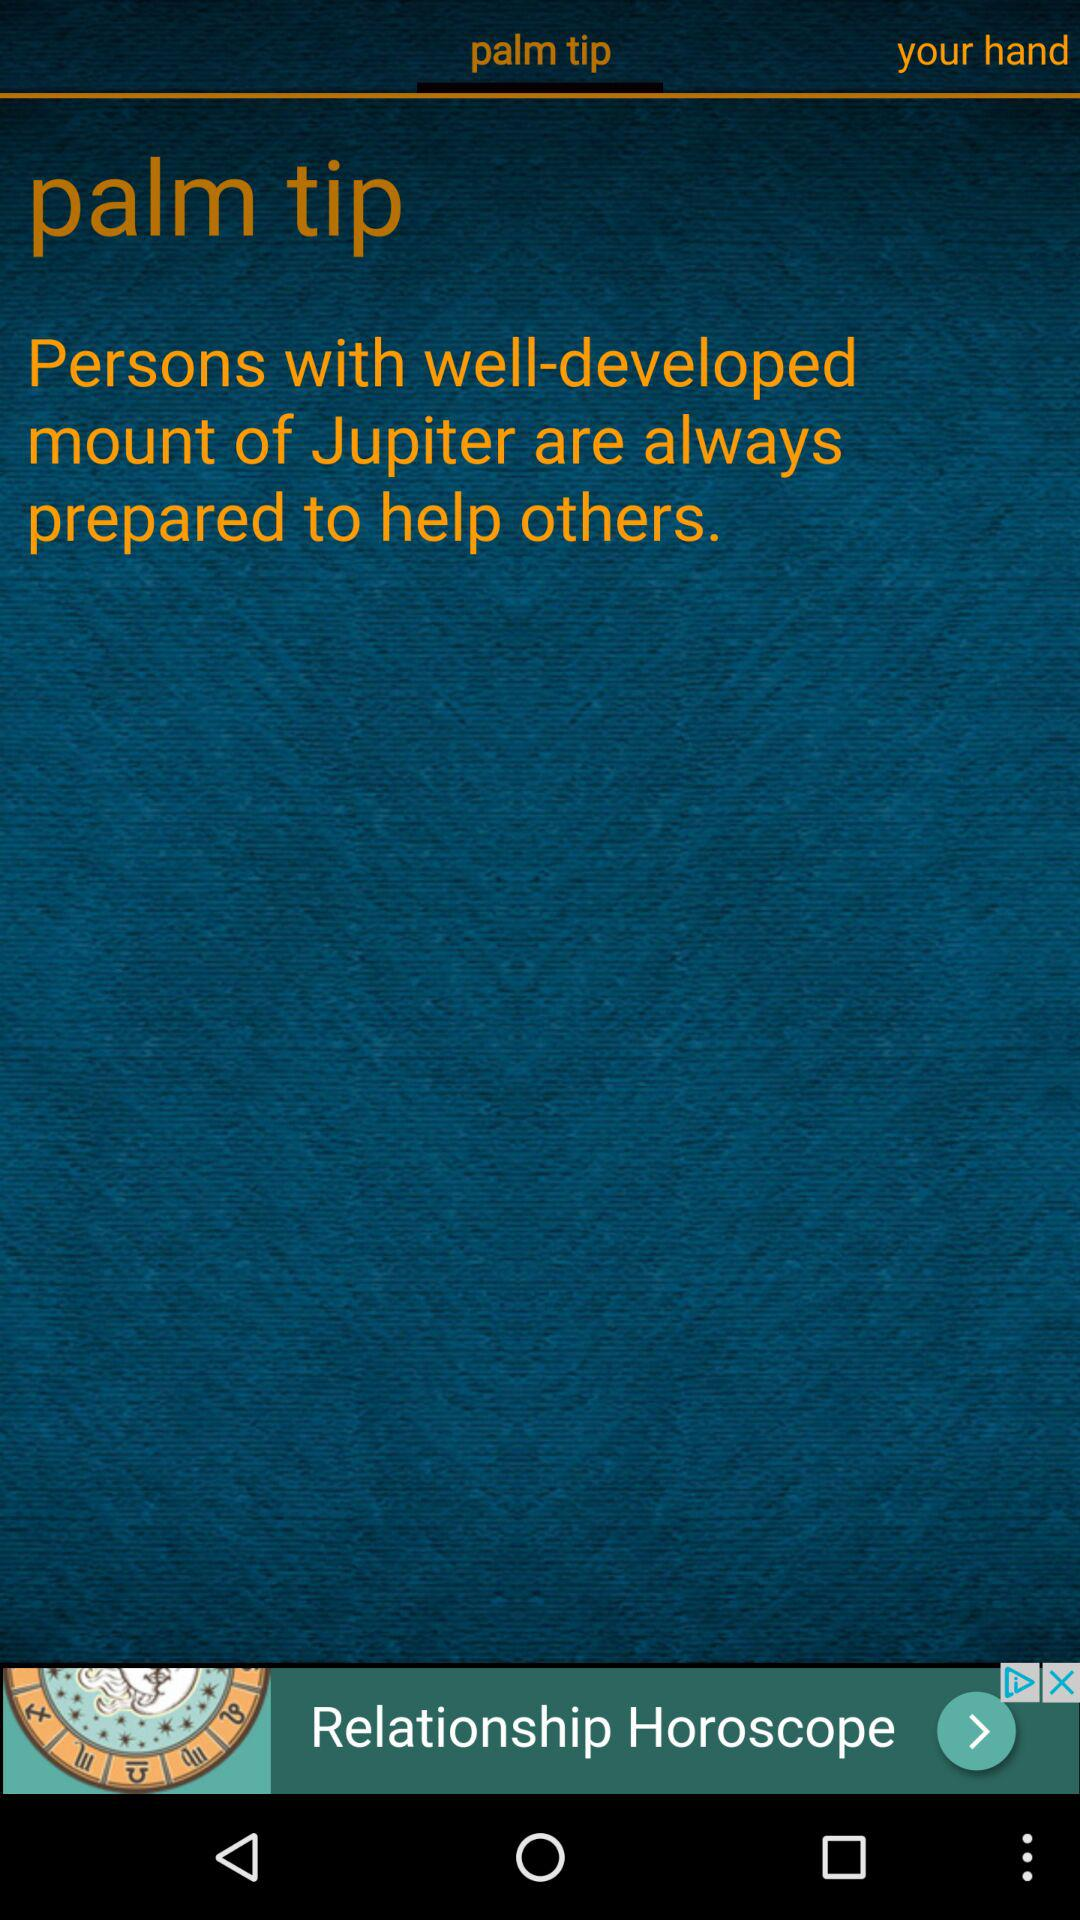Who is always prepared to help others? To help others, people with well-developed mount of Jupiter are always prepared. 